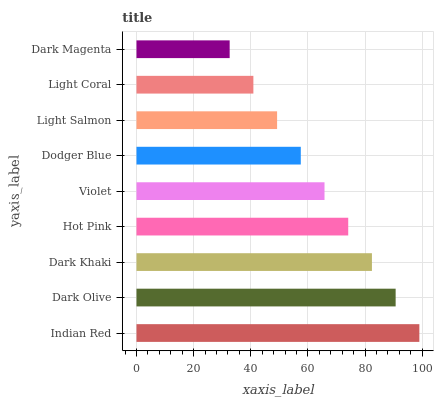Is Dark Magenta the minimum?
Answer yes or no. Yes. Is Indian Red the maximum?
Answer yes or no. Yes. Is Dark Olive the minimum?
Answer yes or no. No. Is Dark Olive the maximum?
Answer yes or no. No. Is Indian Red greater than Dark Olive?
Answer yes or no. Yes. Is Dark Olive less than Indian Red?
Answer yes or no. Yes. Is Dark Olive greater than Indian Red?
Answer yes or no. No. Is Indian Red less than Dark Olive?
Answer yes or no. No. Is Violet the high median?
Answer yes or no. Yes. Is Violet the low median?
Answer yes or no. Yes. Is Light Coral the high median?
Answer yes or no. No. Is Light Coral the low median?
Answer yes or no. No. 